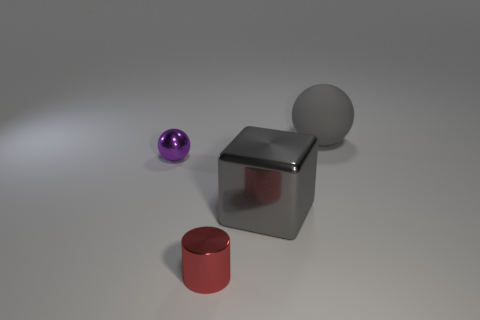What material is the sphere that is the same size as the metal block?
Your answer should be compact. Rubber. There is a metallic thing on the right side of the small shiny thing right of the small purple object; what size is it?
Provide a succinct answer. Large. Does the ball on the left side of the gray matte thing have the same size as the block?
Ensure brevity in your answer.  No. Is the number of small purple things in front of the tiny purple shiny thing greater than the number of red metallic cylinders right of the gray ball?
Offer a terse response. No. What is the shape of the object that is in front of the small purple metal ball and on the left side of the big shiny block?
Offer a terse response. Cylinder. What is the shape of the big thing behind the block?
Keep it short and to the point. Sphere. There is a gray object that is in front of the sphere to the right of the tiny thing on the left side of the small red cylinder; what size is it?
Your answer should be compact. Large. Does the tiny purple metal thing have the same shape as the large gray rubber thing?
Your answer should be compact. Yes. There is a metal thing that is both on the left side of the large gray block and behind the small red metallic cylinder; how big is it?
Provide a short and direct response. Small. What is the material of the other small object that is the same shape as the rubber thing?
Your answer should be compact. Metal. 